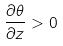Convert formula to latex. <formula><loc_0><loc_0><loc_500><loc_500>\frac { \partial \theta } { \partial z } > 0</formula> 